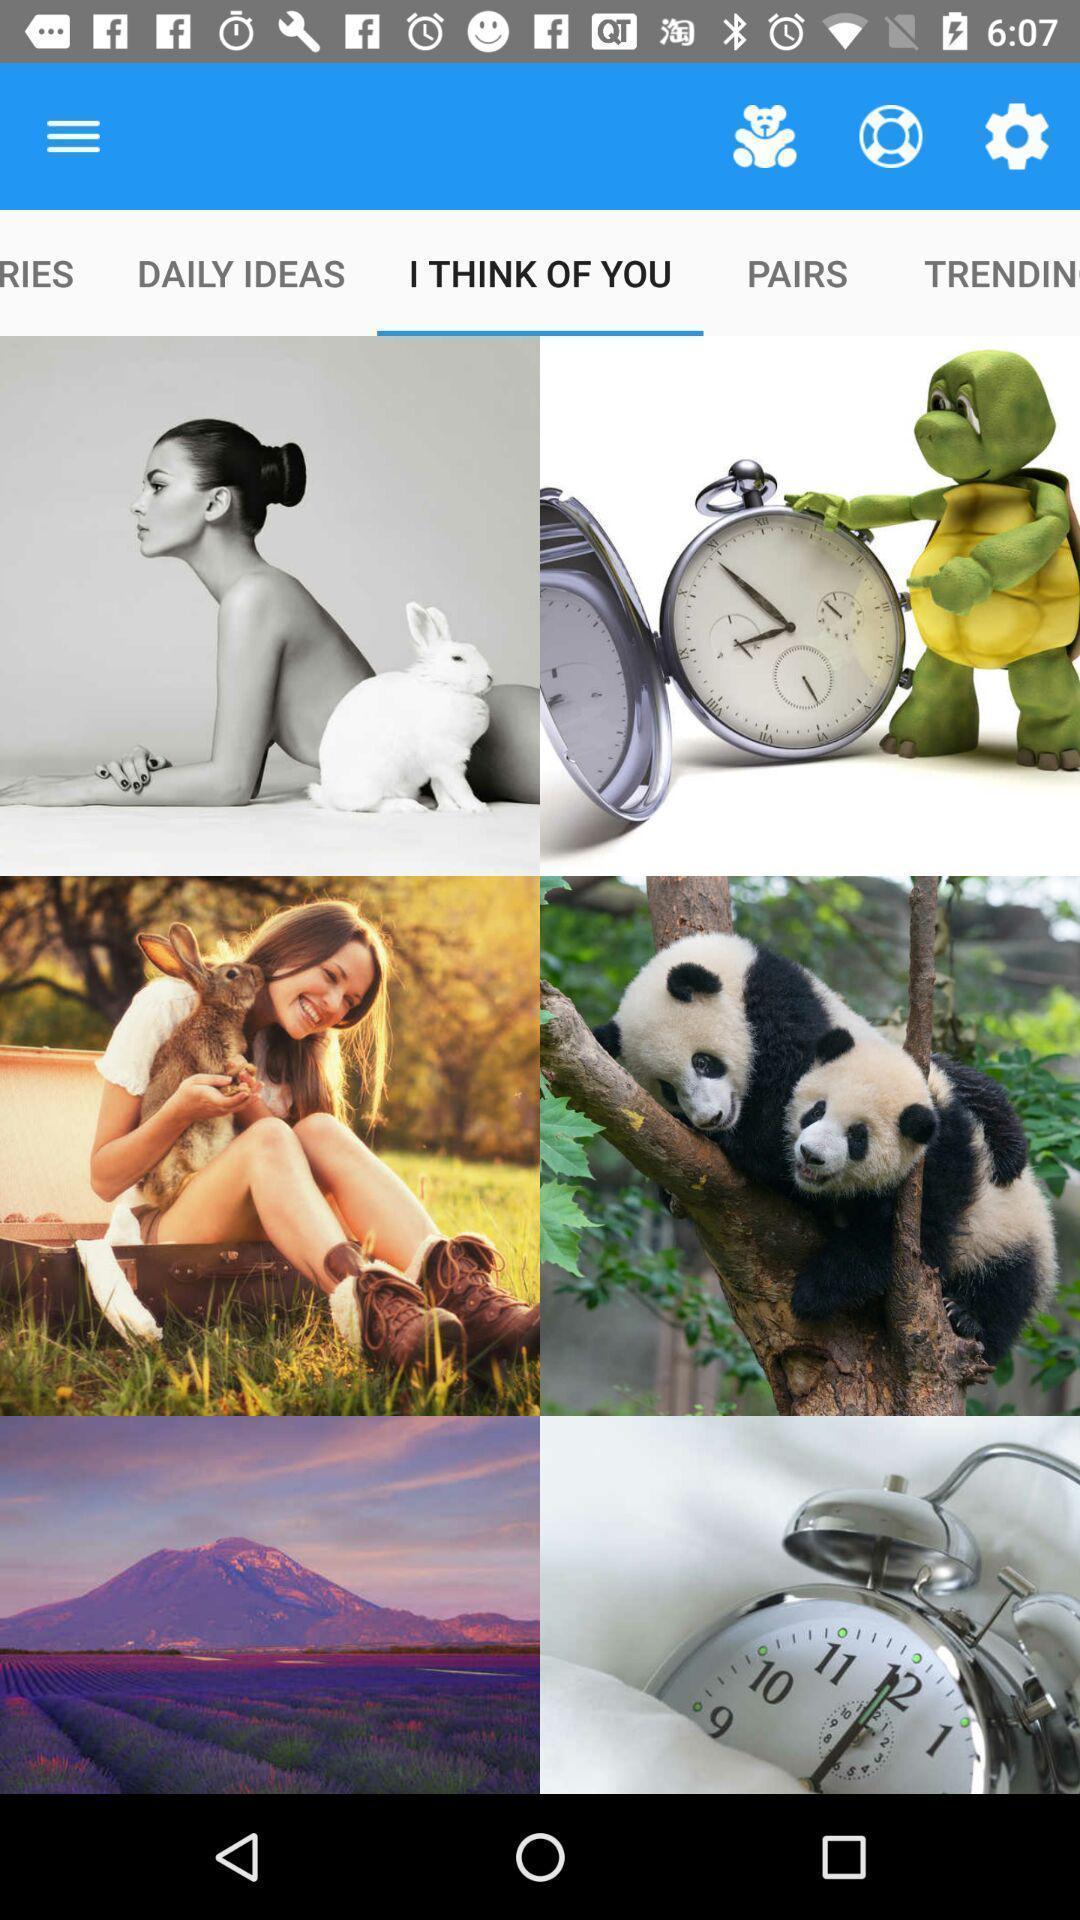Summarize the main components in this picture. Screen shows stickers page in emoji app. 